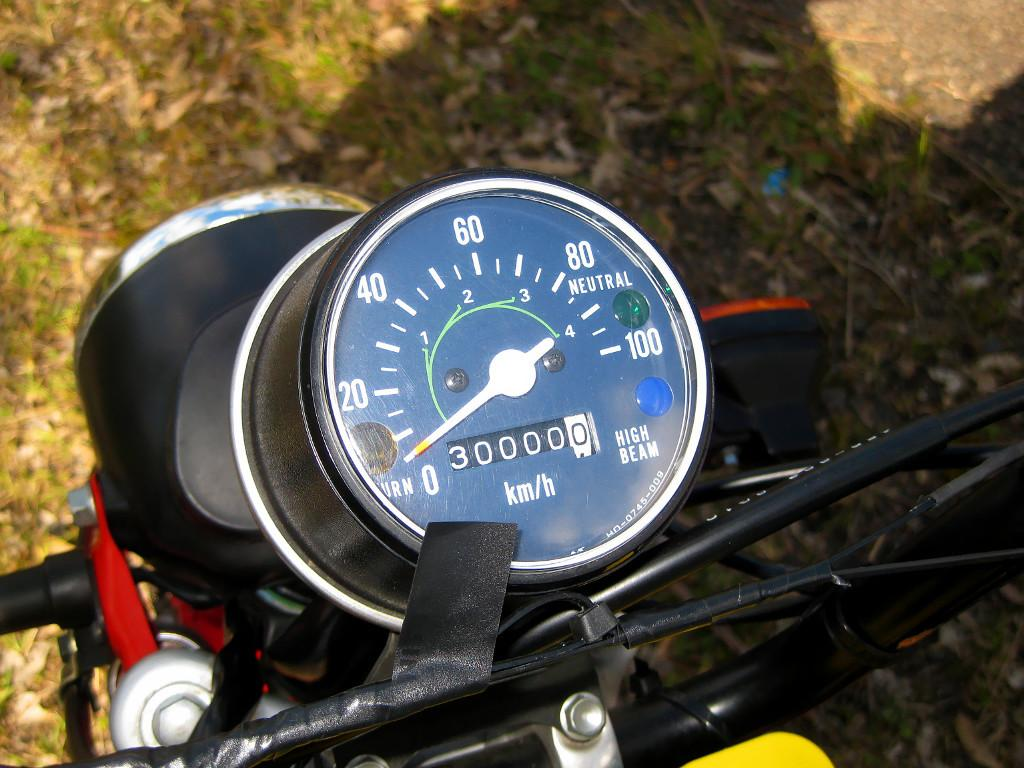What is the main subject of the picture? The main subject of the picture is a motorcycle. What feature can be seen on the motorcycle? The motorcycle has an odometer. What type of terrain is visible in the picture? There is grass visible on the ground. What flavor of dust can be seen on the motorcycle in the image? There is no dust visible on the motorcycle in the image, and therefore no flavor can be determined. 